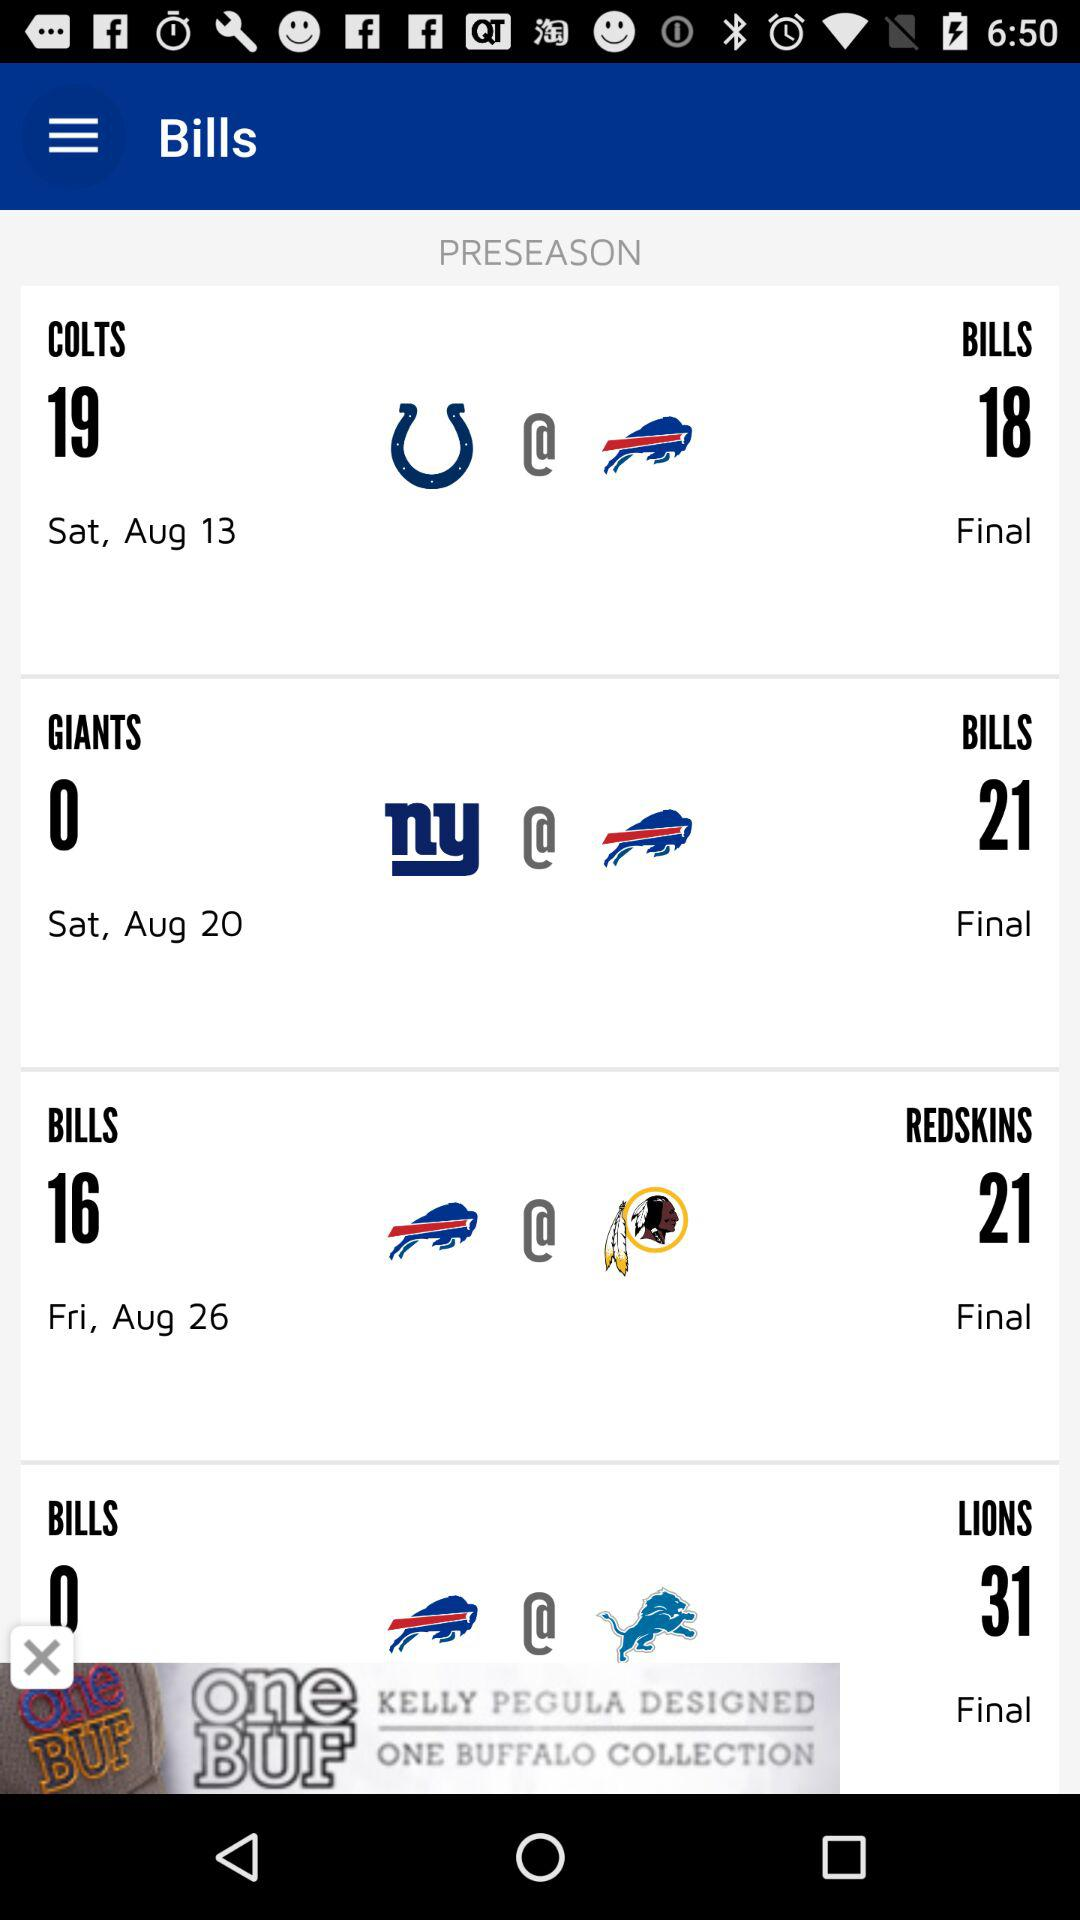How many games are in the preseason schedule?
Answer the question using a single word or phrase. 4 